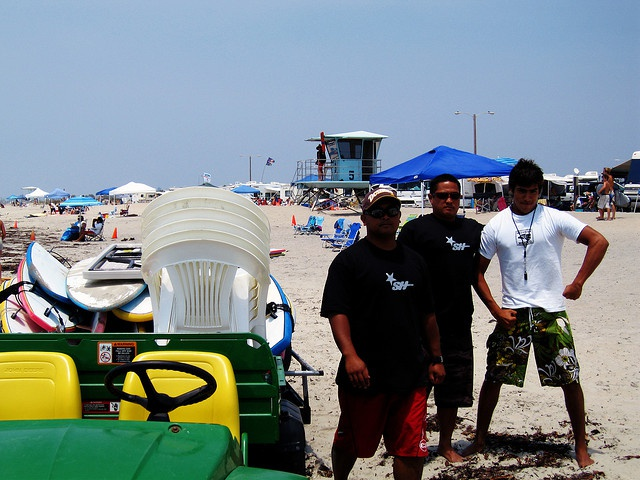Describe the objects in this image and their specific colors. I can see car in lightblue, black, darkgray, lightgray, and green tones, people in lightblue, black, maroon, and darkgray tones, people in lightblue, black, lavender, and darkgray tones, people in lightblue, black, maroon, darkgray, and gray tones, and chair in lightblue, darkgray, and lightgray tones in this image. 